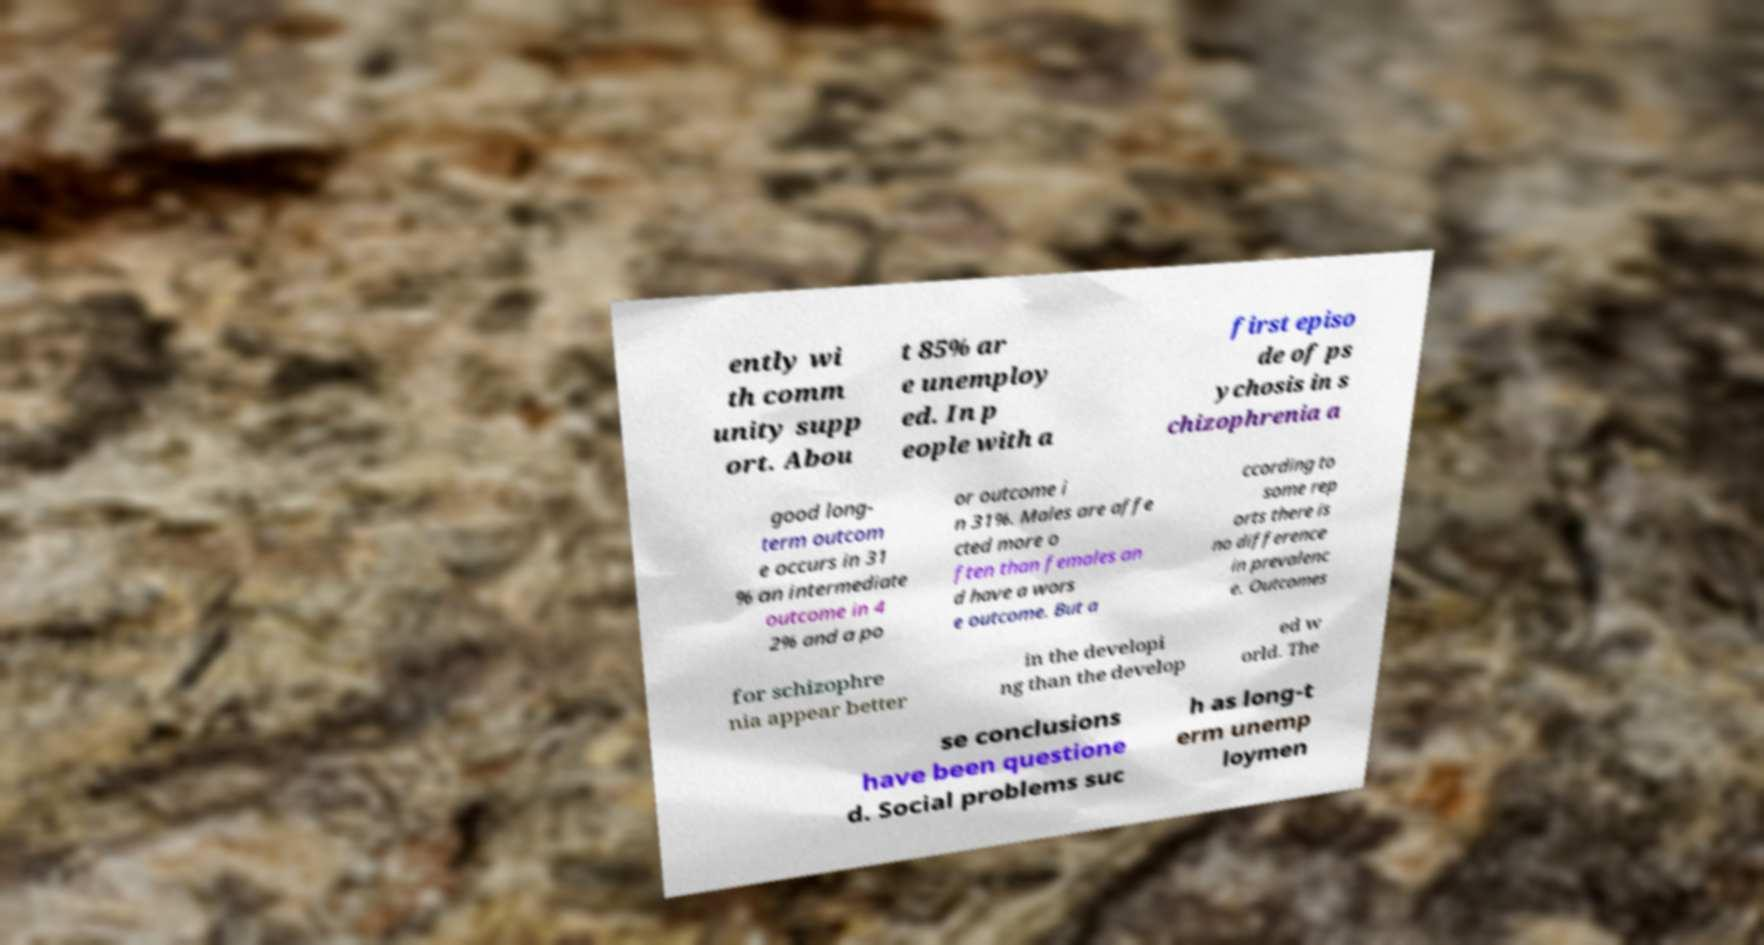There's text embedded in this image that I need extracted. Can you transcribe it verbatim? ently wi th comm unity supp ort. Abou t 85% ar e unemploy ed. In p eople with a first episo de of ps ychosis in s chizophrenia a good long- term outcom e occurs in 31 % an intermediate outcome in 4 2% and a po or outcome i n 31%. Males are affe cted more o ften than females an d have a wors e outcome. But a ccording to some rep orts there is no difference in prevalenc e. Outcomes for schizophre nia appear better in the developi ng than the develop ed w orld. The se conclusions have been questione d. Social problems suc h as long-t erm unemp loymen 